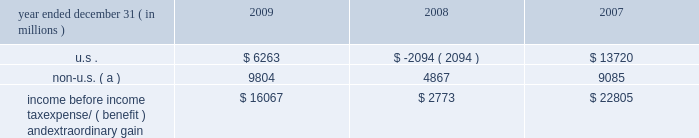Notes to consolidated financial statements jpmorgan chase & co./2009 annual report 236 the table presents the u.s .
And non-u.s .
Components of income before income tax expense/ ( benefit ) and extraordinary gain for the years ended december 31 , 2009 , 2008 and 2007 .
Year ended december 31 , ( in millions ) 2009 2008 2007 .
Non-u.s. ( a ) 9804 4867 9085 income before income tax expense/ ( benefit ) and extraordinary gain $ 16067 $ 2773 $ 22805 ( a ) for purposes of this table , non-u.s .
Income is defined as income generated from operations located outside the u.s .
Note 28 2013 restrictions on cash and inter- company funds transfers the business of jpmorgan chase bank , national association ( 201cjpmorgan chase bank , n.a . 201d ) is subject to examination and regulation by the office of the comptroller of the currency ( 201cocc 201d ) .
The bank is a member of the u.s .
Federal reserve sys- tem , and its deposits are insured by the fdic .
The board of governors of the federal reserve system ( the 201cfed- eral reserve 201d ) requires depository institutions to maintain cash reserves with a federal reserve bank .
The average amount of reserve balances deposited by the firm 2019s bank subsidiaries with various federal reserve banks was approximately $ 821 million and $ 1.6 billion in 2009 and 2008 , respectively .
Restrictions imposed by u.s .
Federal law prohibit jpmorgan chase and certain of its affiliates from borrowing from banking subsidiar- ies unless the loans are secured in specified amounts .
Such secured loans to the firm or to other affiliates are generally limited to 10% ( 10 % ) of the banking subsidiary 2019s total capital , as determined by the risk- based capital guidelines ; the aggregate amount of all such loans is limited to 20% ( 20 % ) of the banking subsidiary 2019s total capital .
The principal sources of jpmorgan chase 2019s income ( on a parent company 2013only basis ) are dividends and interest from jpmorgan chase bank , n.a. , and the other banking and nonbanking subsidi- aries of jpmorgan chase .
In addition to dividend restrictions set forth in statutes and regulations , the federal reserve , the occ and the fdic have authority under the financial institutions supervisory act to prohibit or to limit the payment of dividends by the banking organizations they supervise , including jpmorgan chase and its subsidiaries that are banks or bank holding companies , if , in the banking regulator 2019s opinion , payment of a dividend would consti- tute an unsafe or unsound practice in light of the financial condi- tion of the banking organization .
At january 1 , 2010 and 2009 , jpmorgan chase 2019s banking subsidi- aries could pay , in the aggregate , $ 3.6 billion and $ 17.0 billion , respectively , in dividends to their respective bank holding compa- nies without the prior approval of their relevant banking regulators .
The capacity to pay dividends in 2010 will be supplemented by the banking subsidiaries 2019 earnings during the year .
In compliance with rules and regulations established by u.s .
And non-u.s .
Regulators , as of december 31 , 2009 and 2008 , cash in the amount of $ 24.0 billion and $ 34.8 billion , respectively , and securities with a fair value of $ 10.2 billion and $ 23.4 billion , re- spectively , were segregated in special bank accounts for the benefit of securities and futures brokerage customers .
Note 29 2013 capital the federal reserve establishes capital requirements , including well-capitalized standards for the consolidated financial holding company .
The occ establishes similar capital requirements and standards for the firm 2019s national banks , including jpmorgan chase bank , n.a. , and chase bank usa , n.a .
There are two categories of risk-based capital : tier 1 capital and tier 2 capital .
Tier 1 capital includes common stockholders 2019 equity , qualifying preferred stock and minority interest less goodwill and other adjustments .
Tier 2 capital consists of preferred stock not qualifying as tier 1 , subordinated long-term debt and other instru- ments qualifying as tier 2 , and the aggregate allowance for credit losses up to a certain percentage of risk-weighted assets .
Total regulatory capital is subject to deductions for investments in certain subsidiaries .
Under the risk-based capital guidelines of the federal reserve , jpmorgan chase is required to maintain minimum ratios of tier 1 and total ( tier 1 plus tier 2 ) capital to risk-weighted assets , as well as minimum leverage ratios ( which are defined as tier 1 capital to average adjusted on 2013balance sheet assets ) .
Failure to meet these minimum requirements could cause the federal reserve to take action .
Banking subsidiaries also are subject to these capital requirements by their respective primary regulators .
As of december 31 , 2009 and 2008 , jpmorgan chase and all of its banking sub- sidiaries were well-capitalized and met all capital requirements to which each was subject. .
For december 31 , 2009 , what was the total value of segregated collateral for the benefit of brokerage customers in millions? 
Computations: (24.0 + 10.2)
Answer: 34.2. 